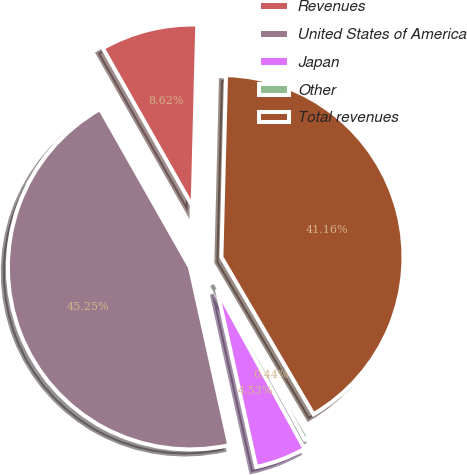Convert chart. <chart><loc_0><loc_0><loc_500><loc_500><pie_chart><fcel>Revenues<fcel>United States of America<fcel>Japan<fcel>Other<fcel>Total revenues<nl><fcel>8.62%<fcel>45.25%<fcel>4.53%<fcel>0.44%<fcel>41.16%<nl></chart> 